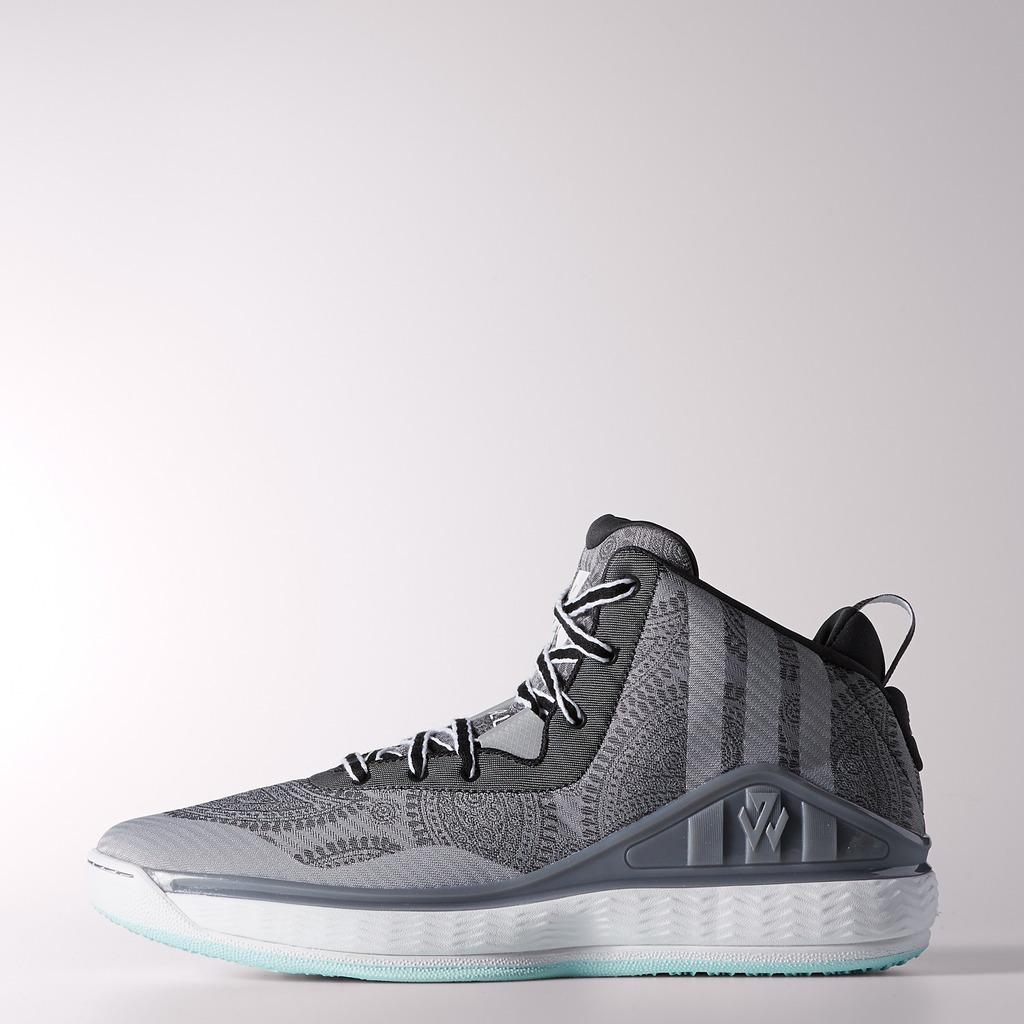What object is the main subject of the image? There is a shoe in the image. What color is the background of the image? The background of the image is white. What type of plantation can be seen in the background of the image? There is no plantation present in the image; the background is white. 